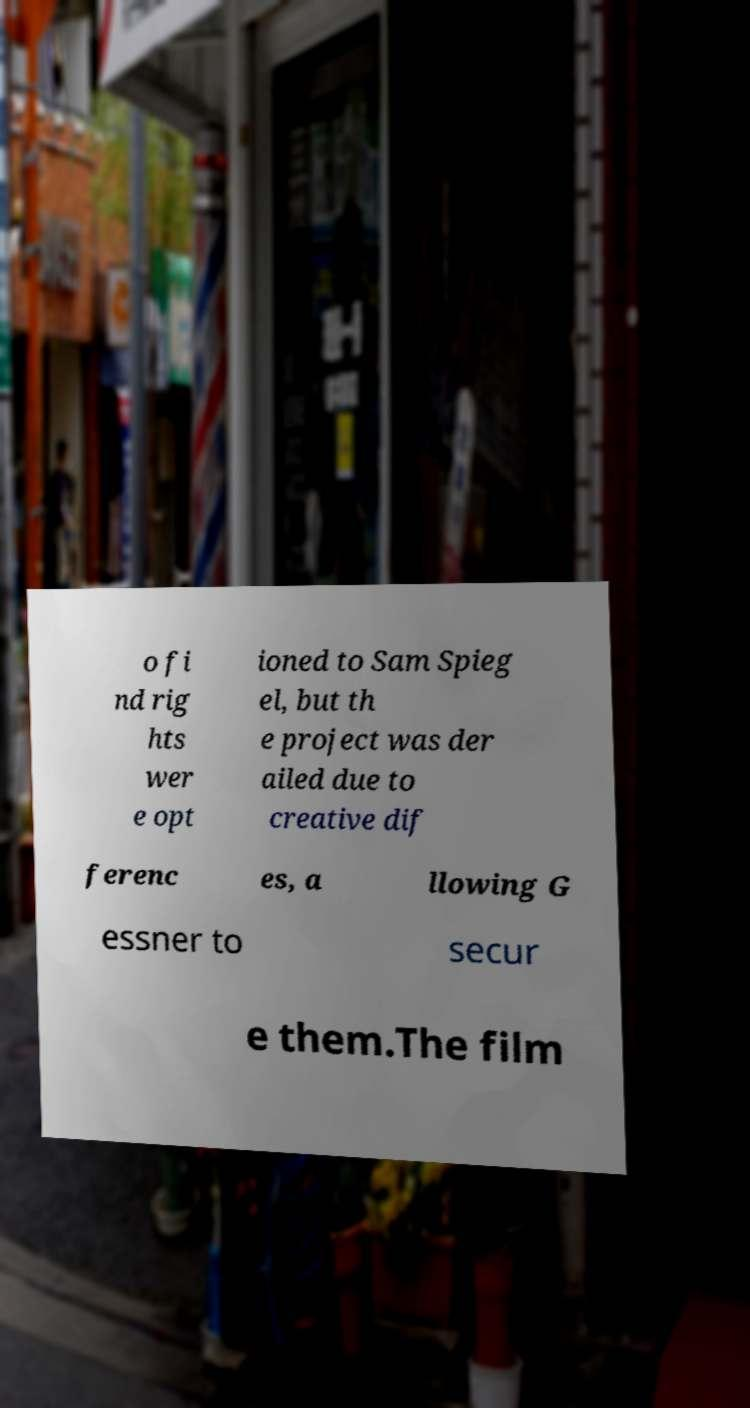There's text embedded in this image that I need extracted. Can you transcribe it verbatim? o fi nd rig hts wer e opt ioned to Sam Spieg el, but th e project was der ailed due to creative dif ferenc es, a llowing G essner to secur e them.The film 